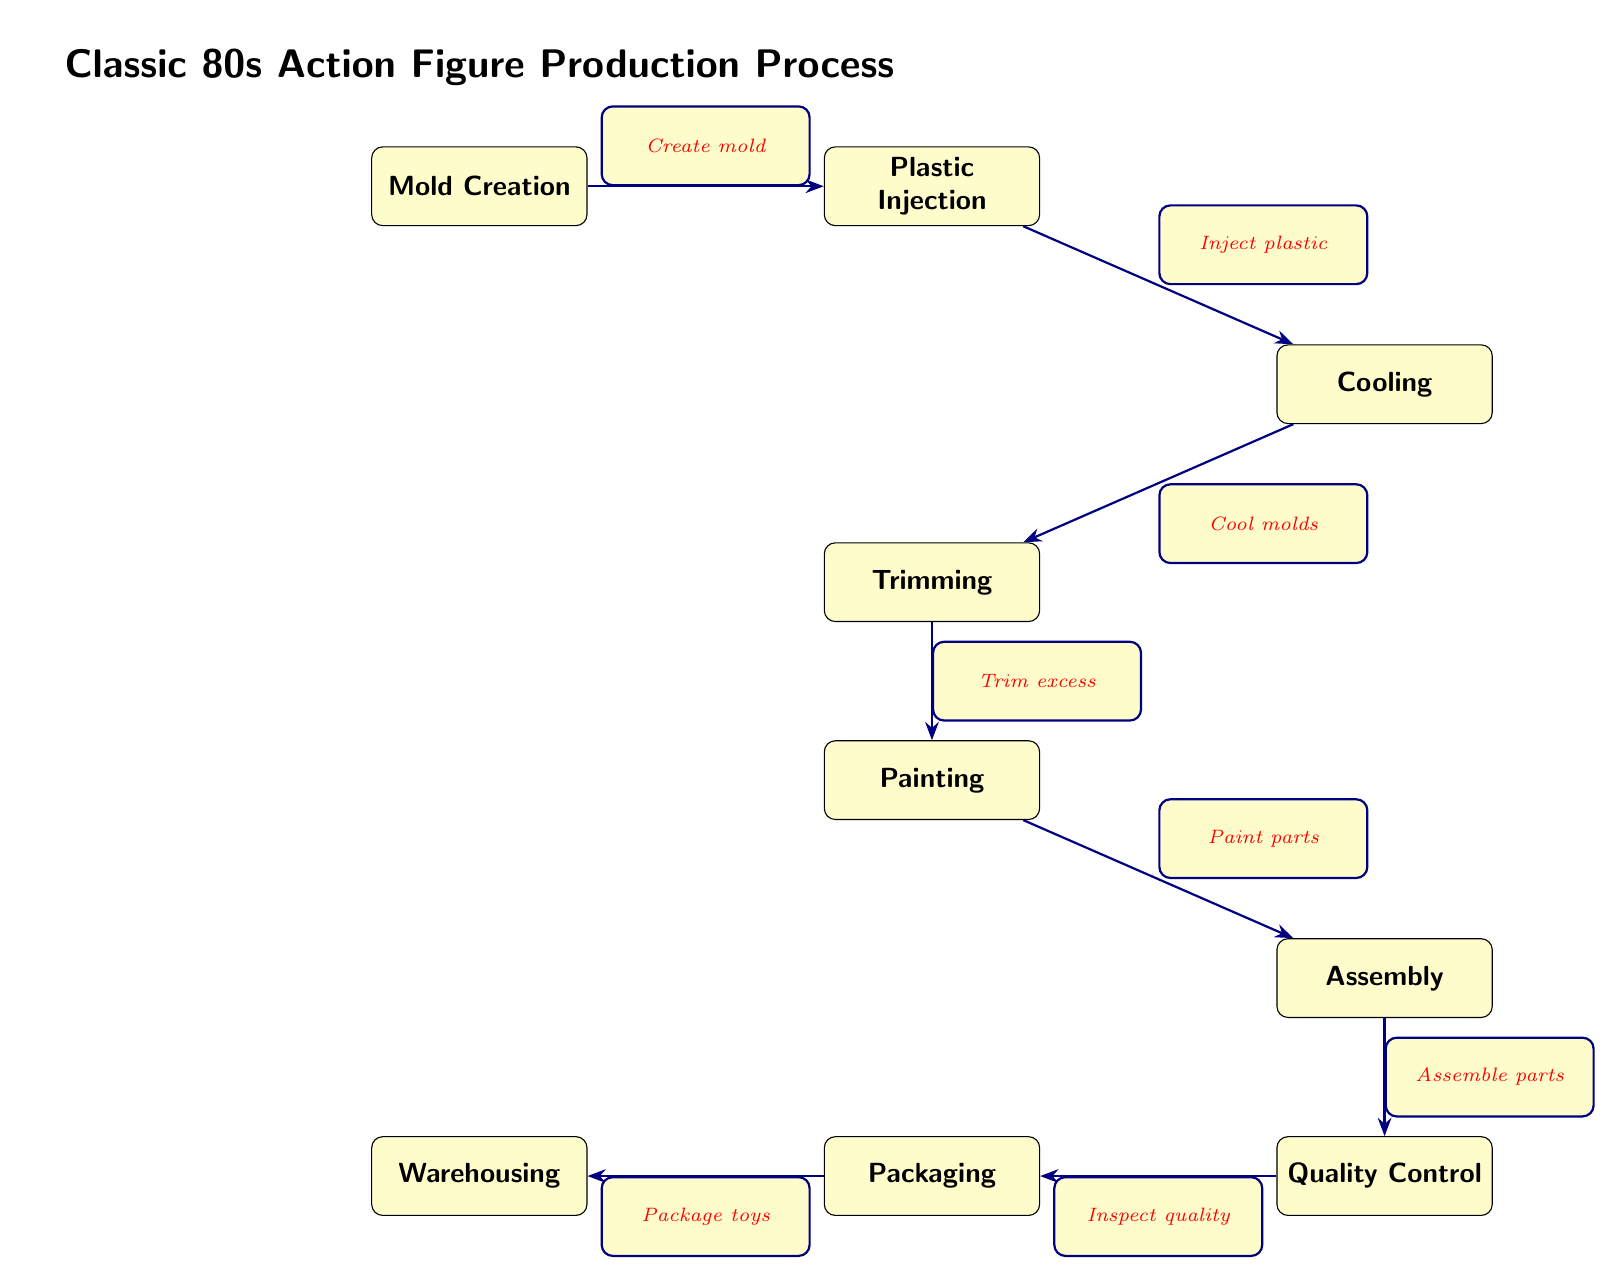What is the first step in the production process? The diagram lists "Mold Creation" as the first node representing the initial step in the process.
Answer: Mold Creation How many steps are there in total? The diagram consists of eight nodes representing the various steps; counting them gives us a total of eight.
Answer: 8 What action is performed after "Plastic Injection"? The next node following "Plastic Injection" is "Cooling," indicating the action performed after the injection process.
Answer: Cooling Which step comes before "Quality Control"? The diagram shows "Assembly" as the step directly preceding "Quality Control," indicating that assembly occurs first.
Answer: Assembly How many nodes lead to "Warehousing"? "Warehousing" is the final node, and it is reached after one node, which is "Packaging," showing that there's only one path to get there.
Answer: 1 What is the relationship between "Painting" and "Trimming"? In the diagram, "Painting" follows "Trimming," indicating that "Trimming" is a prerequisite for "Painting," thus demonstrating a sequential relationship.
Answer: Trimming What is the last action taken before products are stored? "Packaging" occurs just before the final step of "Warehousing," indicating that packaging is the last action before the products are stored.
Answer: Packaging What do you do after "Inspect quality"? The next step after "Inspect quality" is "Package toys," indicating that packaging follows the quality inspection in the production flow.
Answer: Package toys How does "Mold Creation" connect to "Plastic Injection"? The connection is represented with an edge labeled "Create mold," showing how the first step leads directly to the injection process.
Answer: Create mold 